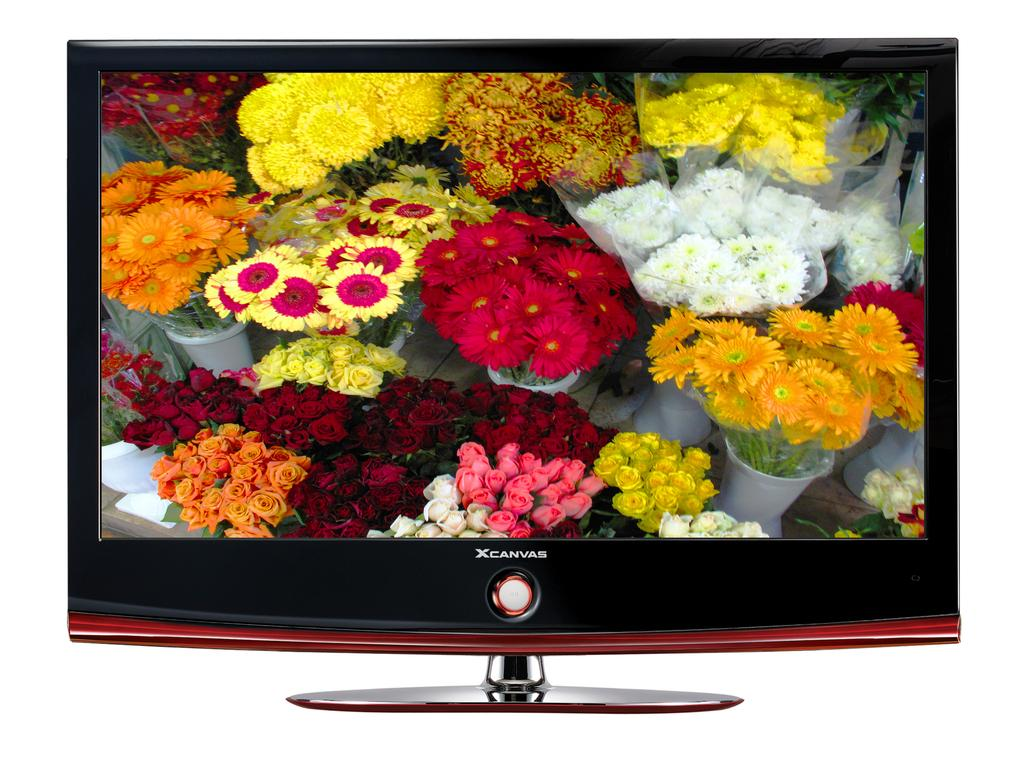<image>
Describe the image concisely. An XCanvas brand TV with lots of flowers all over the screen. 